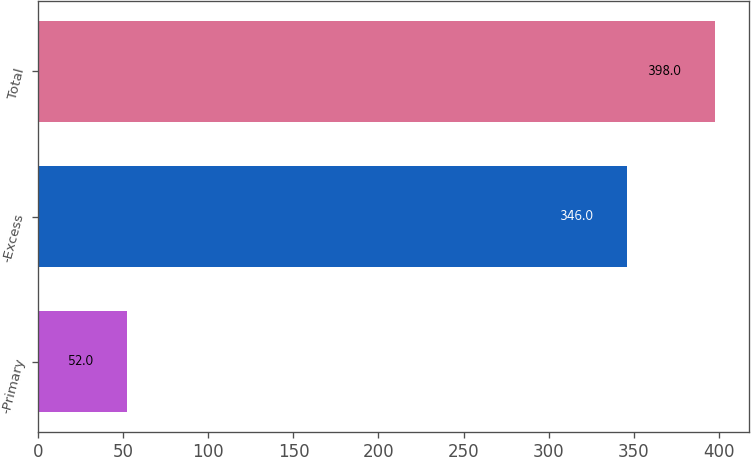Convert chart. <chart><loc_0><loc_0><loc_500><loc_500><bar_chart><fcel>-Primary<fcel>-Excess<fcel>Total<nl><fcel>52<fcel>346<fcel>398<nl></chart> 